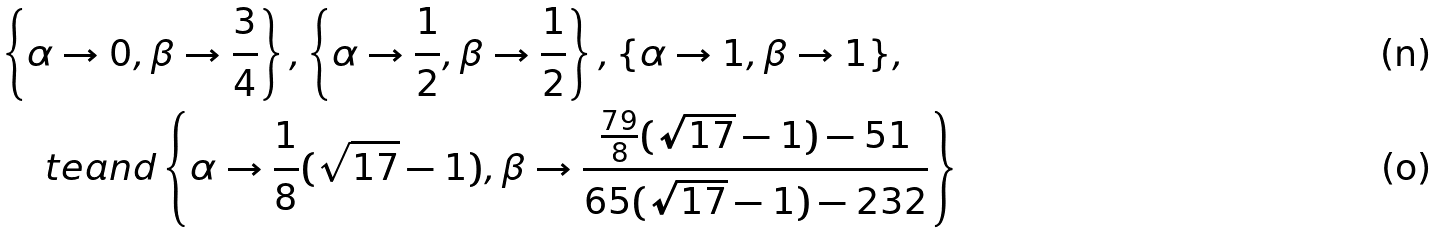Convert formula to latex. <formula><loc_0><loc_0><loc_500><loc_500>& \left \{ \alpha \to 0 , \beta \to \frac { 3 } { 4 } \right \} , \left \{ \alpha \to \frac { 1 } { 2 } , \beta \to \frac { 1 } { 2 } \right \} , \{ \alpha \to 1 , \beta \to 1 \} , \\ & \quad \ t e { a n d } \left \{ \alpha \to \frac { 1 } { 8 } ( \sqrt { 1 7 } - 1 ) , \beta \to \frac { \frac { 7 9 } { 8 } ( \sqrt { 1 7 } - 1 ) - 5 1 } { 6 5 ( \sqrt { 1 7 } - 1 ) - 2 3 2 } \right \}</formula> 